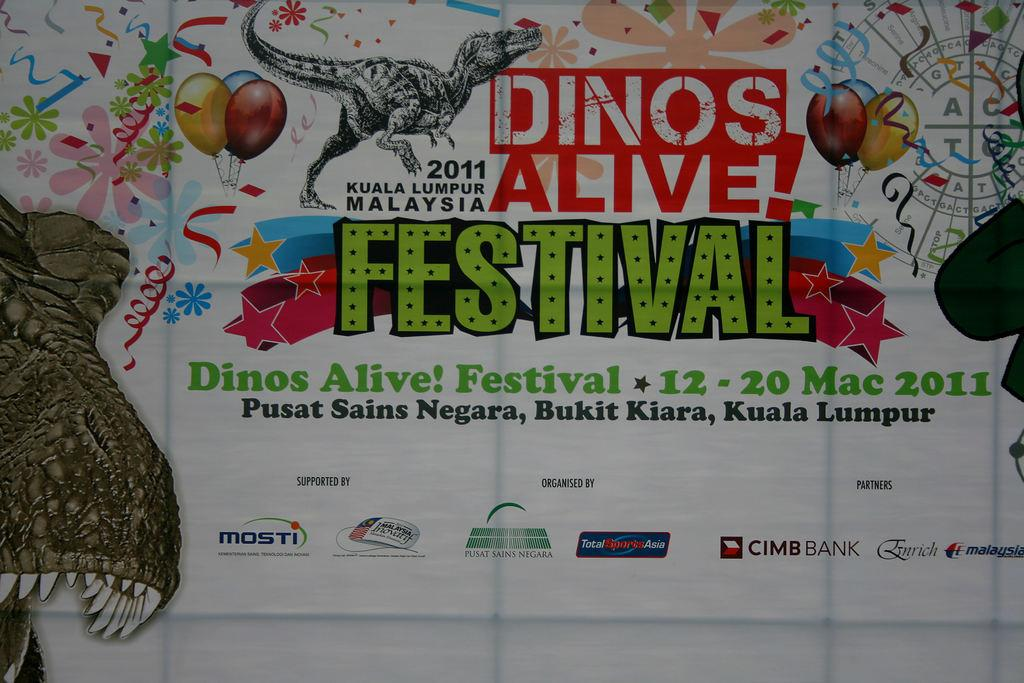What is featured in the image? There is a poster in the image. What is the subject of the poster? The poster is of a festival. Can you see any signs of regret on the faces of the people attending the festival in the poster? There are no faces or expressions visible in the image, as it only features a poster of a festival. 